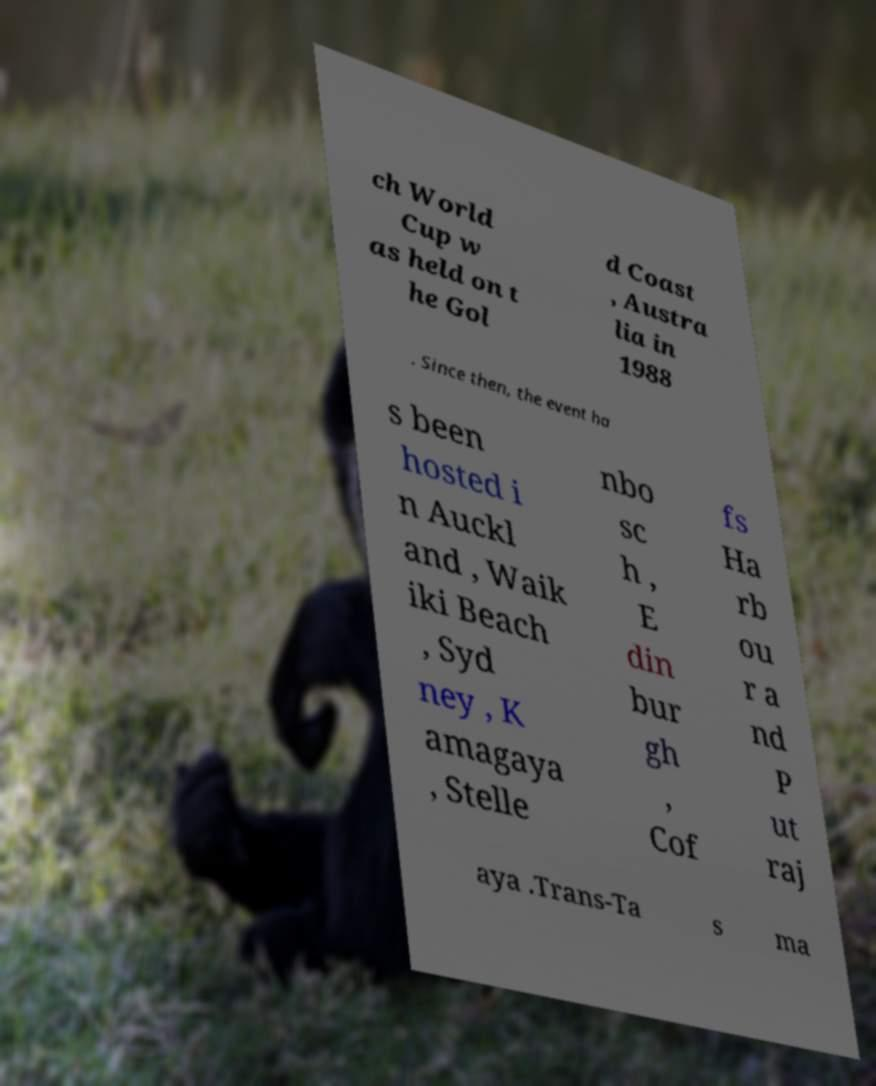What messages or text are displayed in this image? I need them in a readable, typed format. ch World Cup w as held on t he Gol d Coast , Austra lia in 1988 . Since then, the event ha s been hosted i n Auckl and , Waik iki Beach , Syd ney , K amagaya , Stelle nbo sc h , E din bur gh , Cof fs Ha rb ou r a nd P ut raj aya .Trans-Ta s ma 